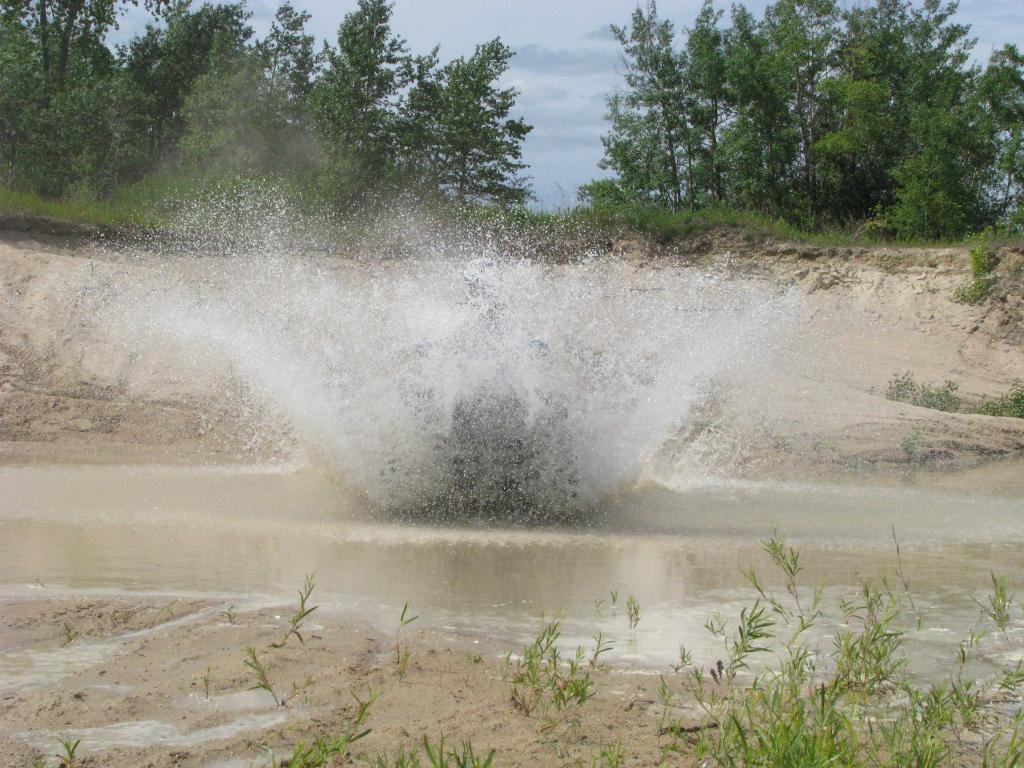What is happening in the image? There is a water splash in the image. How would you describe the water in the image? The water is muddy. What can be seen on the sides of the water? There is sand and grasses on the sides of the water. What is visible in the background of the image? There are trees and the sky in the background of the image. Where is the receipt for the can that was lifted in the image? There is no receipt, can, or lifting action present in the image; it features a water splash with muddy water and a surrounding environment of sand, grasses, trees, and the sky. 